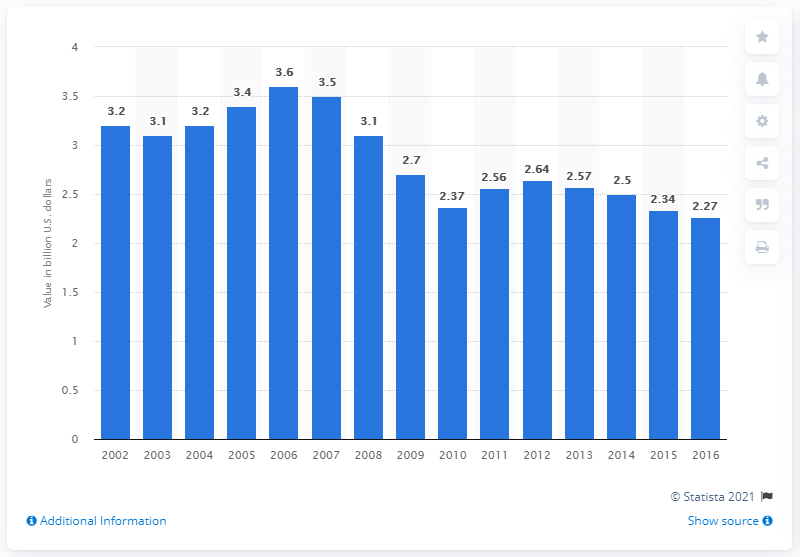Identify some key points in this picture. The value of product shipments of envelopes in the United States in 2009 was approximately 2.7 billion dollars. 